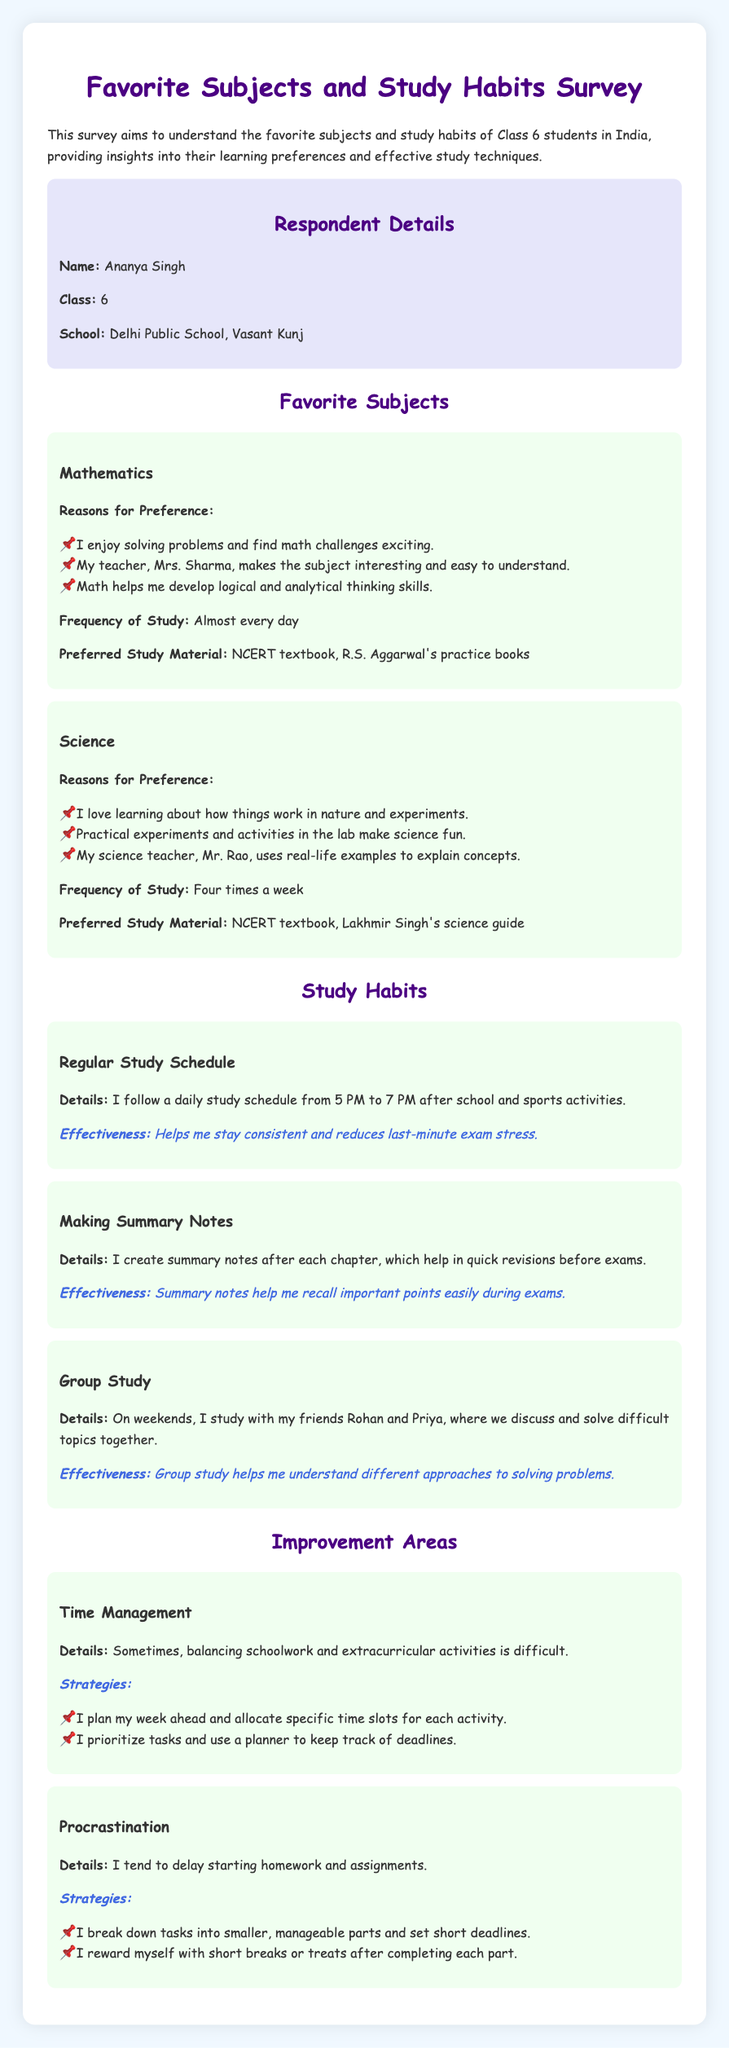What is the name of the respondent? The name of the respondent is mentioned in the respondent details section of the document.
Answer: Ananya Singh Which school does the respondent attend? The school name is provided in the respondent details section of the document.
Answer: Delhi Public School, Vasant Kunj How often does the respondent study Mathematics? The frequency of study for Mathematics is noted in the favorite subjects section.
Answer: Almost every day What is the preferred study material for Science? The preferred study materials for Science are listed in the favorite subjects section.
Answer: NCERT textbook, Lakhmir Singh's science guide What study habit involves creating summary notes? The study habit that involves creating summary notes is identified in the study habits section of the document.
Answer: Making Summary Notes How many times a week does the respondent study Science? The frequency of study for Science is detailed in the favorite subjects section.
Answer: Four times a week Which subjects did the respondent find most enjoyable? The favorite subjects mentioned by the respondent can be found in the favorite subjects section of the document.
Answer: Mathematics, Science What is one of the strategies to manage time effectively? The strategies for improving time management are listed under the improvement areas section.
Answer: I plan my week ahead What is mentioned as a challenge regarding homework? The details about the challenges faced by the respondent can be found in the improvement areas section.
Answer: Procrastination Who are the respondent's friends that they study with? The names of the friends the respondent studies with are included in the group study description.
Answer: Rohan and Priya 